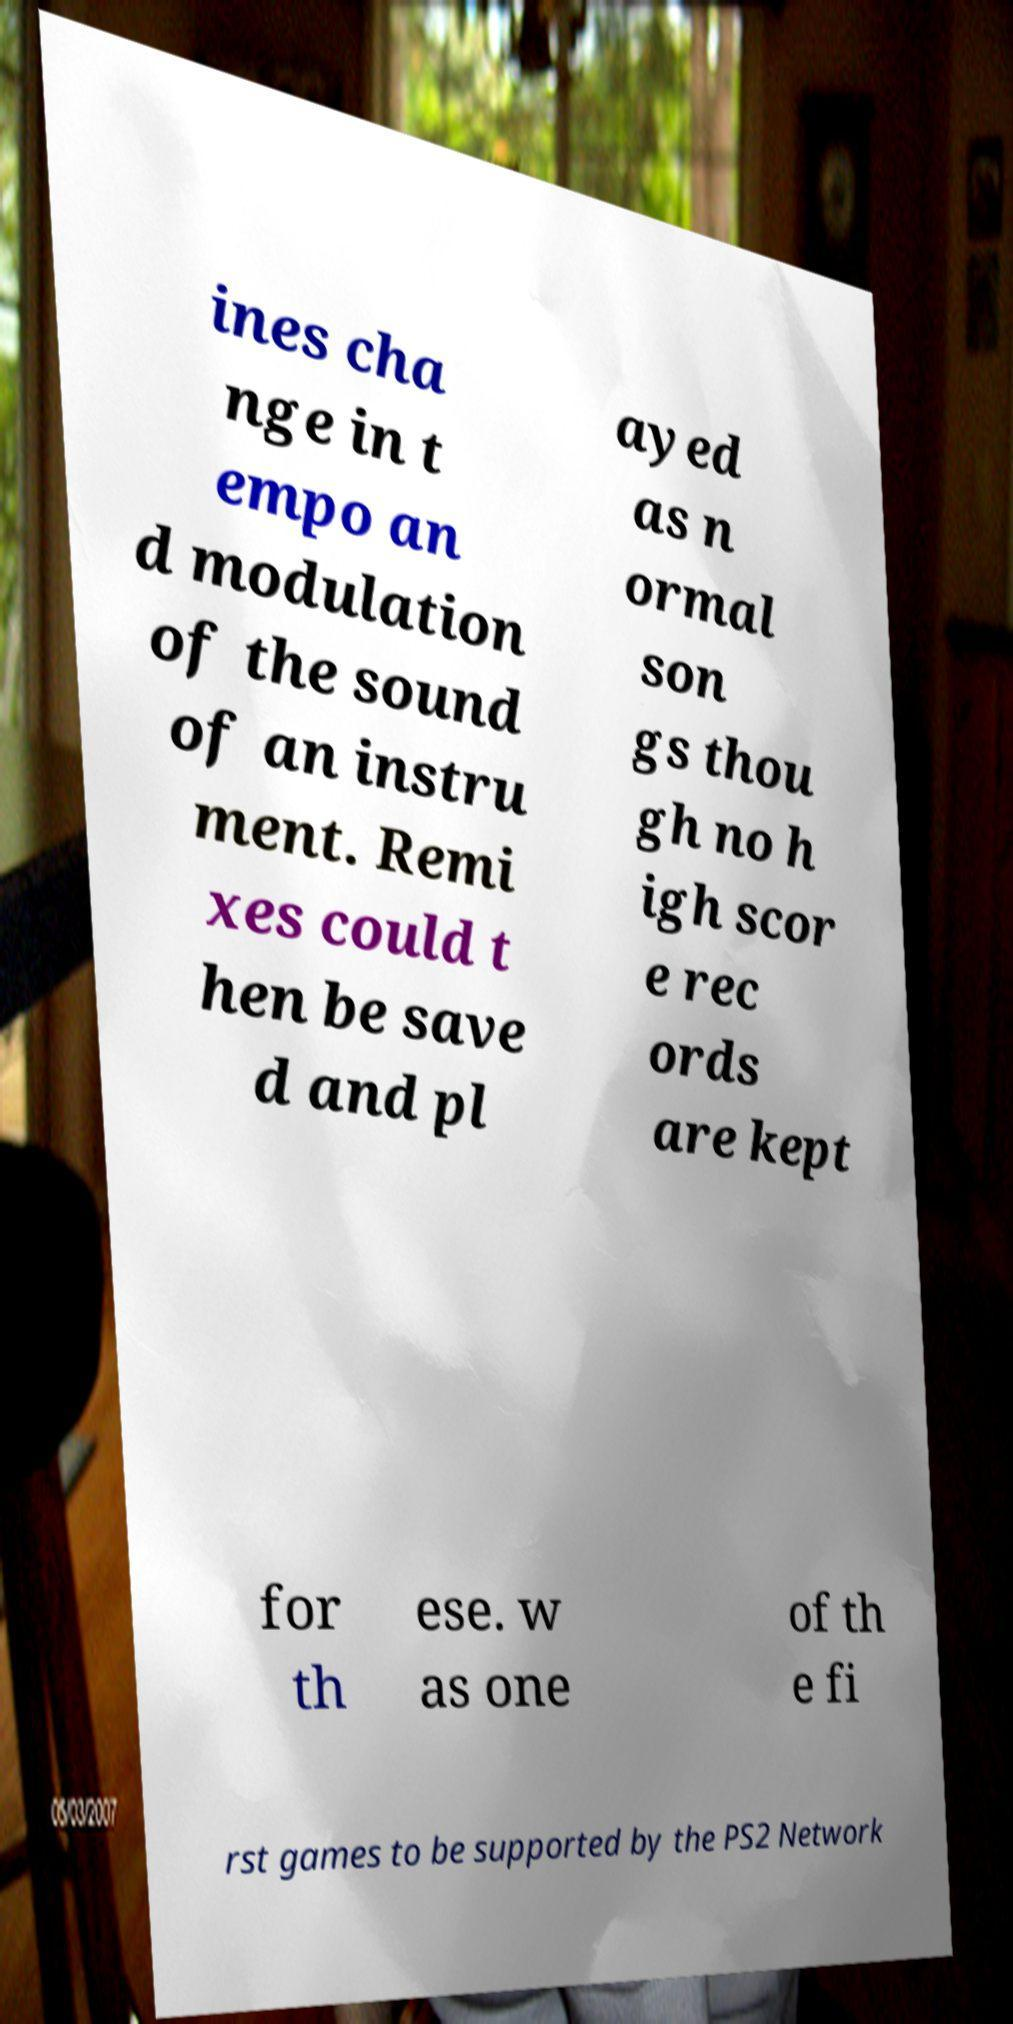Please read and relay the text visible in this image. What does it say? ines cha nge in t empo an d modulation of the sound of an instru ment. Remi xes could t hen be save d and pl ayed as n ormal son gs thou gh no h igh scor e rec ords are kept for th ese. w as one of th e fi rst games to be supported by the PS2 Network 